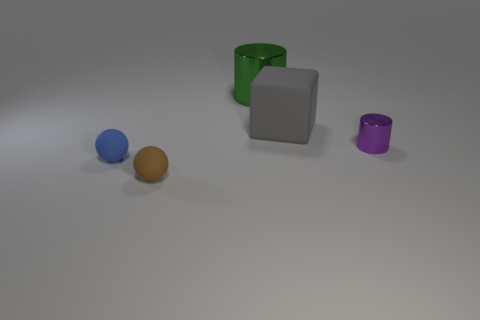Add 2 big green things. How many objects exist? 7 Subtract all cubes. How many objects are left? 4 Add 5 balls. How many balls exist? 7 Subtract 0 gray balls. How many objects are left? 5 Subtract all small yellow matte spheres. Subtract all tiny blue rubber objects. How many objects are left? 4 Add 5 large things. How many large things are left? 7 